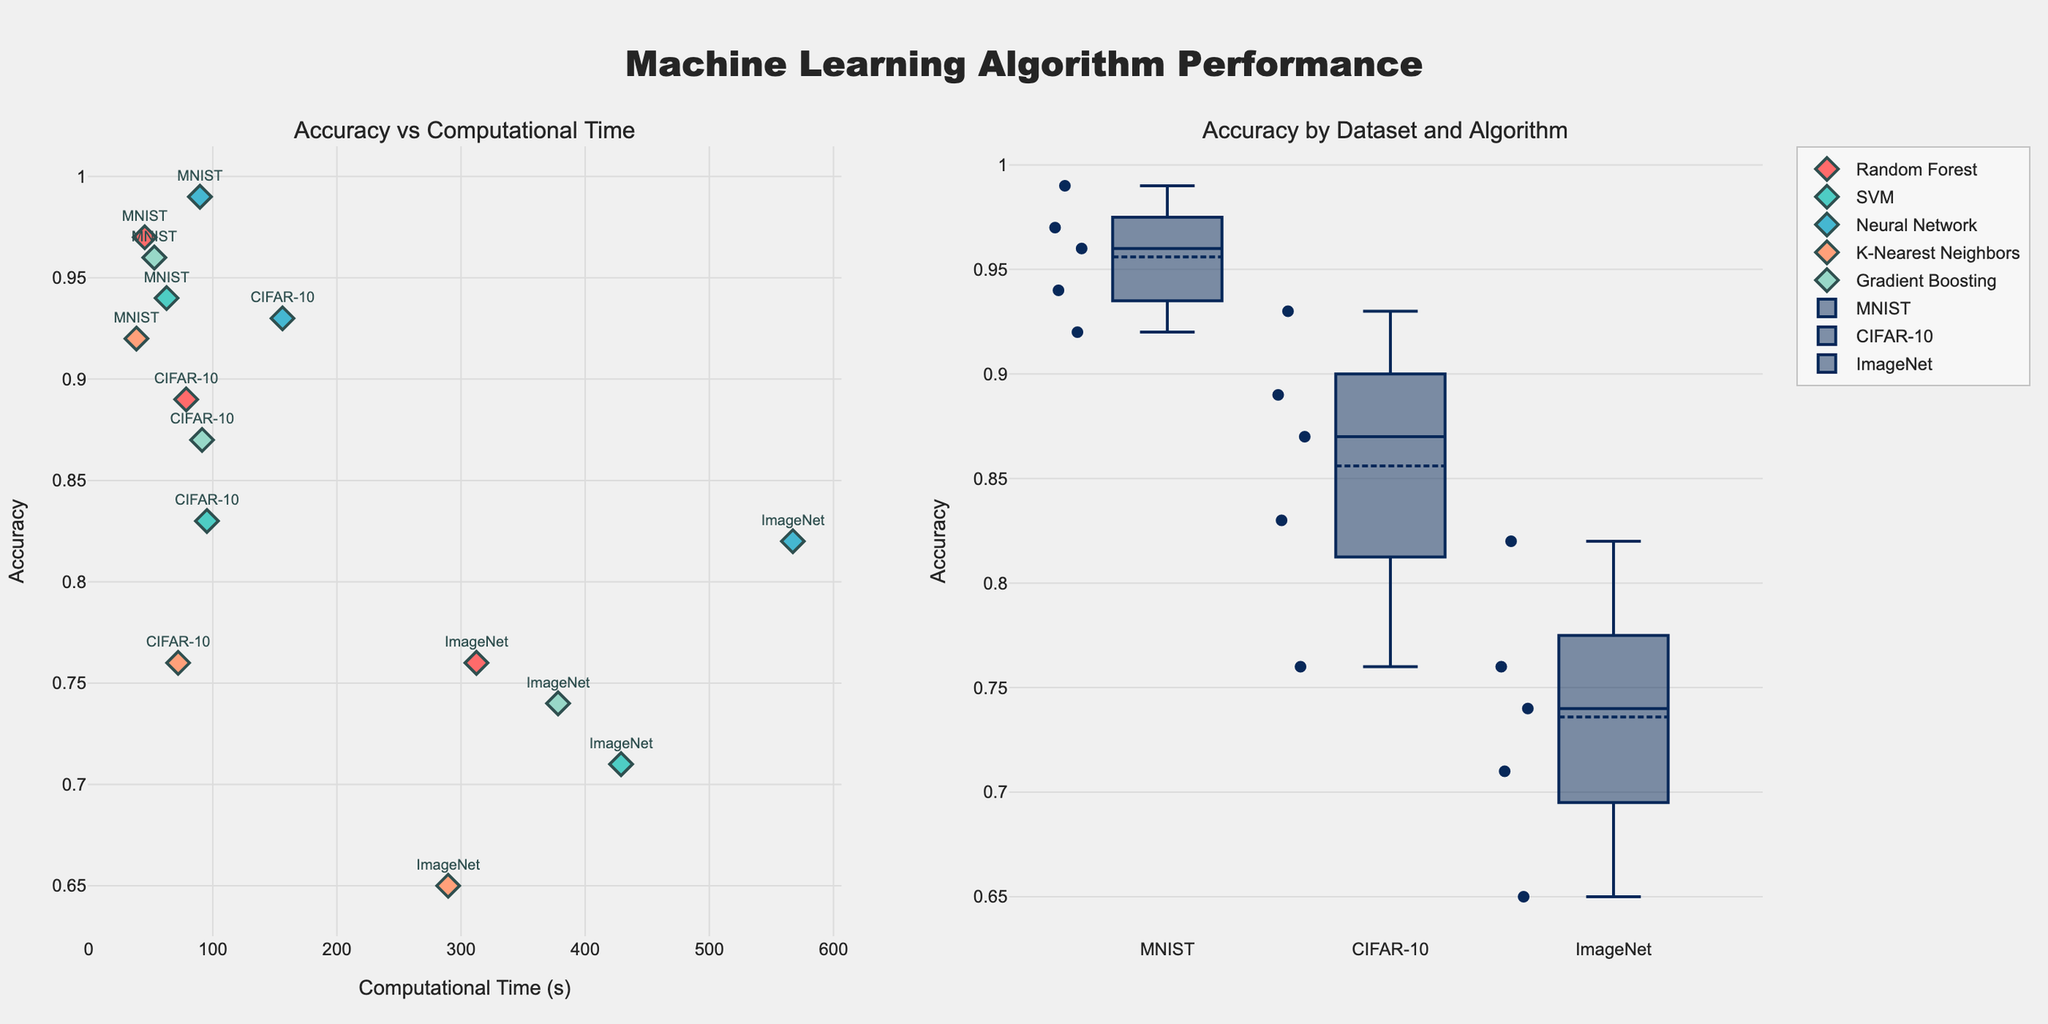What is the overall title of the plot? The overall title is placed at the top center of the plot, which is visually identifiable in large, bold text and reads "Machine Learning Algorithm Performance."
Answer: Machine Learning Algorithm Performance What is the x-axis label of the scatter plot? The x-axis label appears below the x-axis of the scatter plot and indicates the measure represented on the horizontal scale, which is "Computational Time (s)."
Answer: Computational Time (s) Which algorithm shows the highest accuracy on the MNIST dataset? By looking at the scatter plot, the highest dot in the cluster for MNIST indicates the highest accuracy, labeled as "Neural Network" with the highest y-axis value in the MNIST group.
Answer: Neural Network Which dataset shows the largest range of accuracy across all algorithms? The box plot shows the distribution of accuracies for each dataset. The dataset with the largest vertical spread in the box plot represents the largest range. Observing the length of the boxes and whiskers, "ImageNet" has the largest range.
Answer: ImageNet Between Random Forest and SVM on the CIFAR-10 dataset, which algorithm has a higher accuracy, and by how much? In the scatter plot, locate the two respective points for Random Forest and SVM within the CIFAR-10 dataset. The Random Forest point is higher on the y-axis than the SVM point. The difference in their accuracy values is 0.89 - 0.83 = 0.06.
Answer: Random Forest, 0.06 What is the median accuracy for the ImageNet dataset? The median value in a box plot is marked by a horizontal line inside the box. For the ImageNet dataset, locate this line in its respective box, which corresponds to the median accuracy.
Answer: 0.74 What is the computational time for the Neural Network on the ImageNet dataset? In the scatter plot, find the Neural Network point labeled "ImageNet" and follow the point to the x-axis to read the computational time.
Answer: 567.3 How does the accuracy of Gradient Boosting compare between the MNIST and CIFAR-10 datasets? In the scatter plot, compare the Gradient Boosting points in both the MNIST and CIFAR-10 clusters. The point for MNIST is higher on the y-axis, indicating a higher accuracy compared to CIFAR-10.
Answer: Higher in MNIST Which algorithm has the shortest computational time on MNIST, and what is the value? Locate the cluster for the MNIST dataset in the scatter plot and identify the lowest point on the x-axis labeled with the shortest computational time. This point is for "K-Nearest Neighbors." The computational time value is directly read off the axis.
Answer: K-Nearest Neighbors, 38.5 Which algorithm has the most varied accuracy across different datasets, according to the scatter plot? By scanning the scatter plot, identify the algorithm whose points are spread the most across the y-axis (accuracy) among different datasets. "Neural Network" shows significant variation in accuracy across MNIST, CIFAR-10, and ImageNet datasets.
Answer: Neural Network 